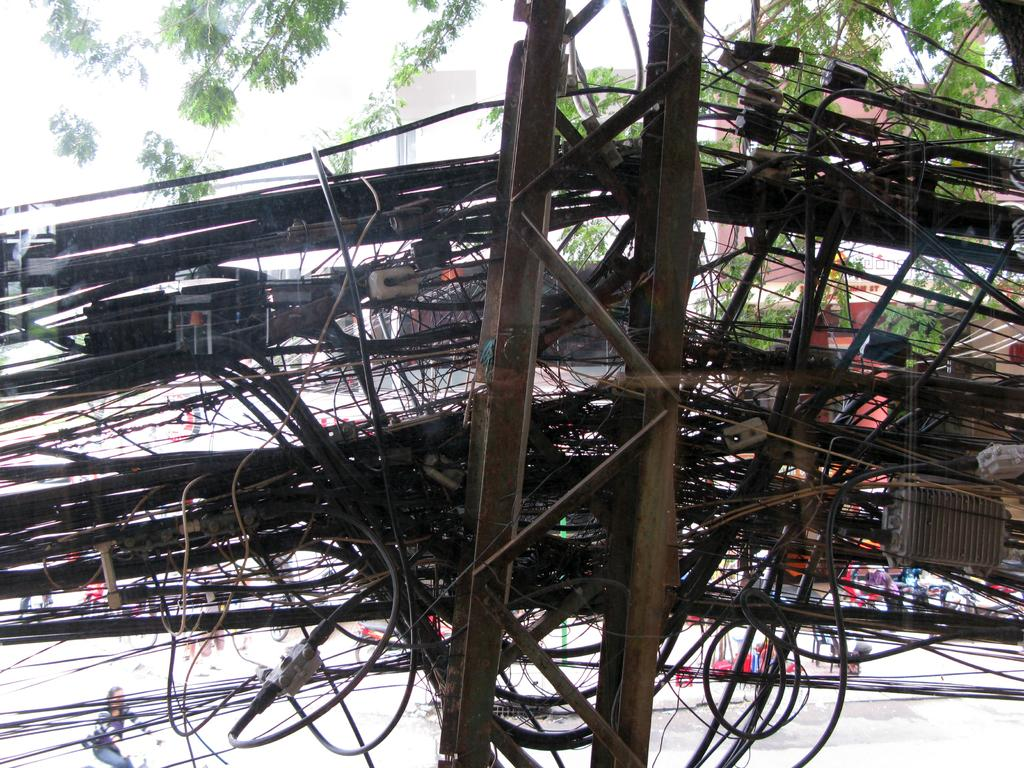What can be seen on the pole in the image? There are cables and devices on a pole in the image. What is happening on the road in the image? There are people and vehicles on the road in the image. What can be seen in the background of the image? There are trees in the background of the image. What type of stone is being processed by the people in the image? There is no stone or process visible in the image; it features a pole with cables and devices, people and vehicles on the road, and trees in the background. What is the source of power for the devices on the pole in the image? The source of power for the devices on the pole is not visible in the image. 